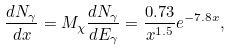Convert formula to latex. <formula><loc_0><loc_0><loc_500><loc_500>\frac { d N _ { \gamma } } { d x } = M _ { \chi } \frac { d N _ { \gamma } } { d E _ { \gamma } } = \frac { 0 . 7 3 } { x ^ { 1 . 5 } } e ^ { - 7 . 8 x } ,</formula> 